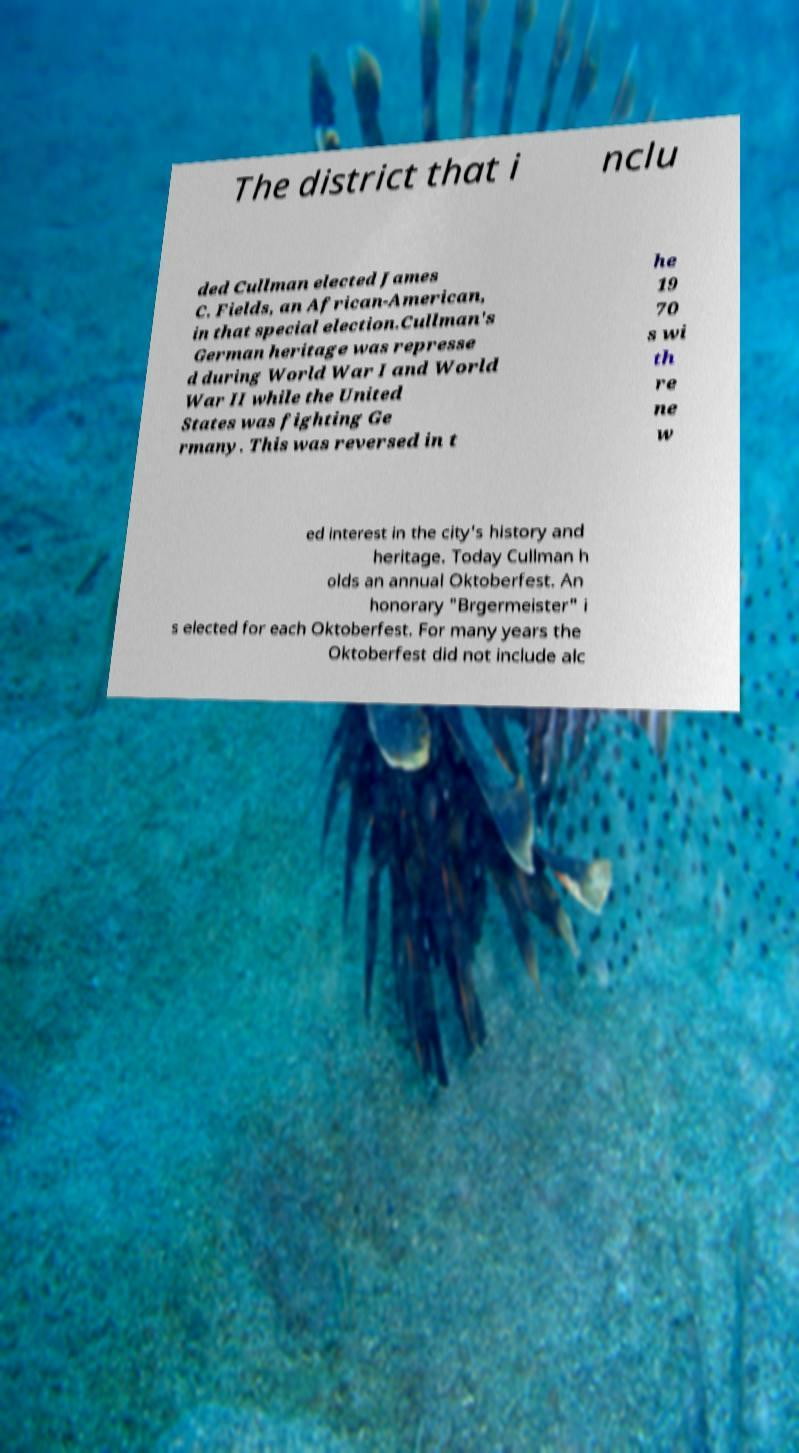Could you extract and type out the text from this image? The district that i nclu ded Cullman elected James C. Fields, an African-American, in that special election.Cullman's German heritage was represse d during World War I and World War II while the United States was fighting Ge rmany. This was reversed in t he 19 70 s wi th re ne w ed interest in the city's history and heritage. Today Cullman h olds an annual Oktoberfest. An honorary "Brgermeister" i s elected for each Oktoberfest. For many years the Oktoberfest did not include alc 